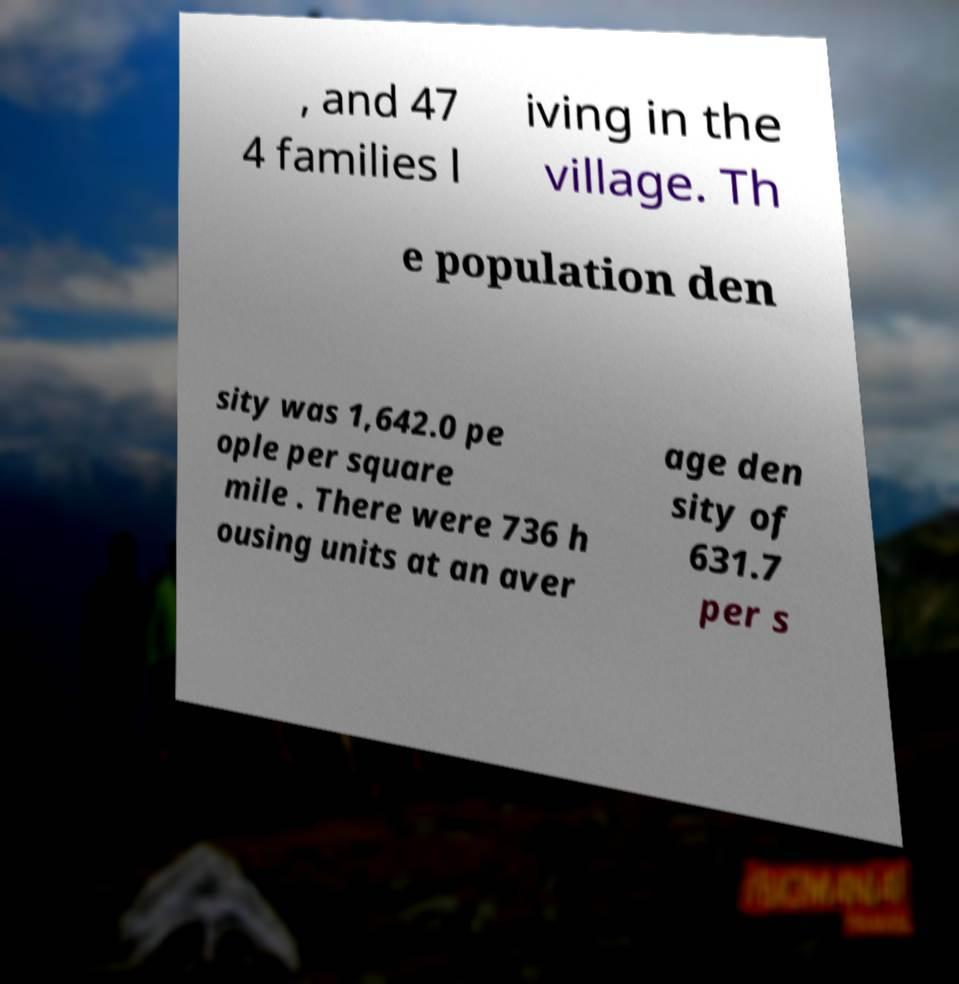Please identify and transcribe the text found in this image. , and 47 4 families l iving in the village. Th e population den sity was 1,642.0 pe ople per square mile . There were 736 h ousing units at an aver age den sity of 631.7 per s 